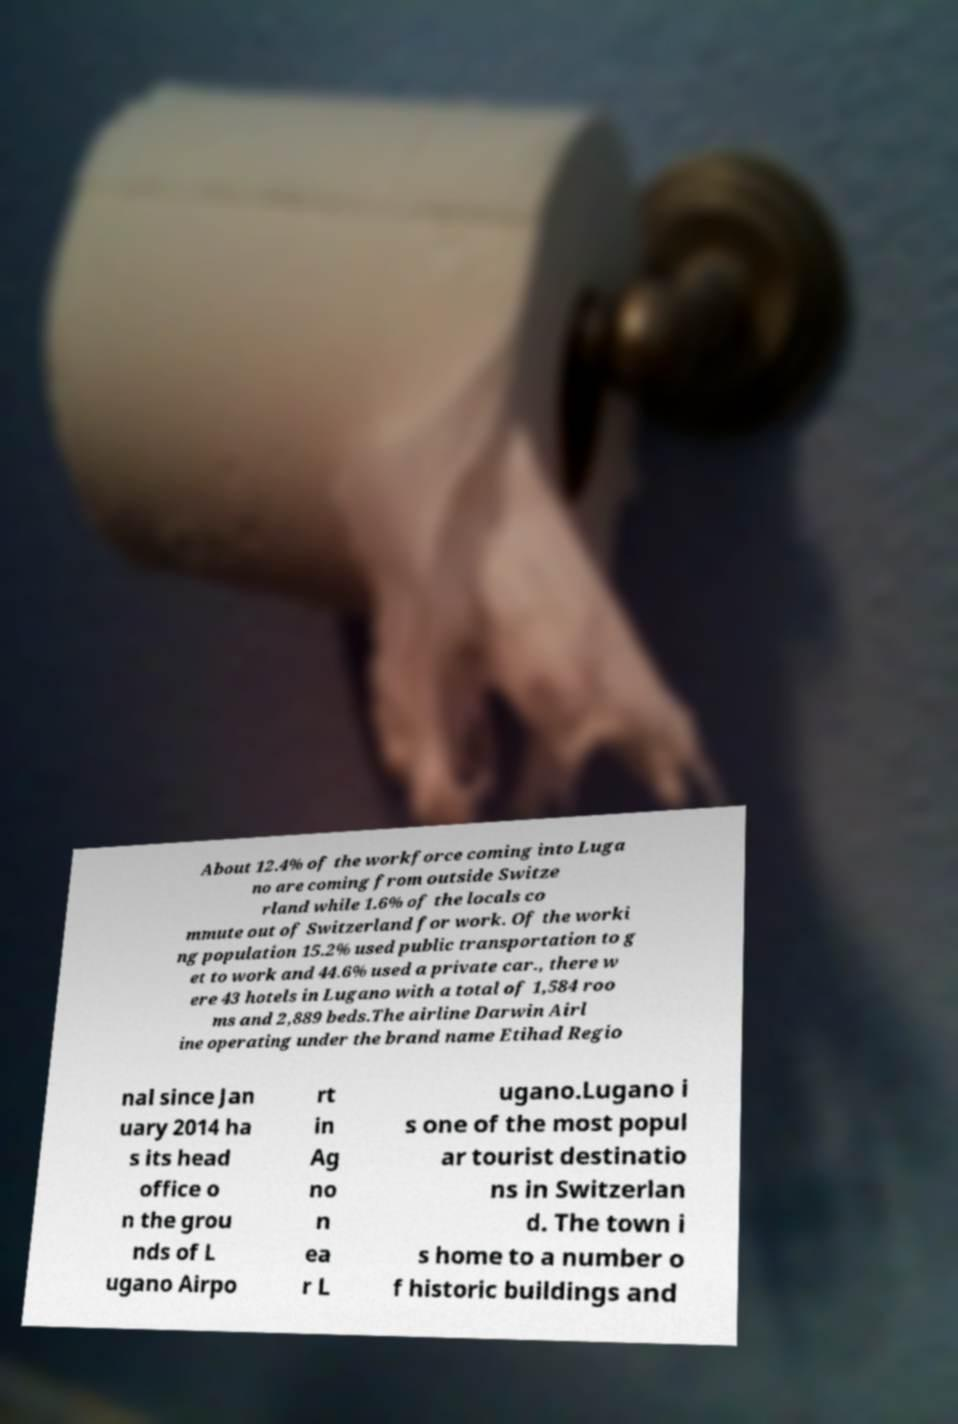Can you read and provide the text displayed in the image?This photo seems to have some interesting text. Can you extract and type it out for me? About 12.4% of the workforce coming into Luga no are coming from outside Switze rland while 1.6% of the locals co mmute out of Switzerland for work. Of the worki ng population 15.2% used public transportation to g et to work and 44.6% used a private car., there w ere 43 hotels in Lugano with a total of 1,584 roo ms and 2,889 beds.The airline Darwin Airl ine operating under the brand name Etihad Regio nal since Jan uary 2014 ha s its head office o n the grou nds of L ugano Airpo rt in Ag no n ea r L ugano.Lugano i s one of the most popul ar tourist destinatio ns in Switzerlan d. The town i s home to a number o f historic buildings and 